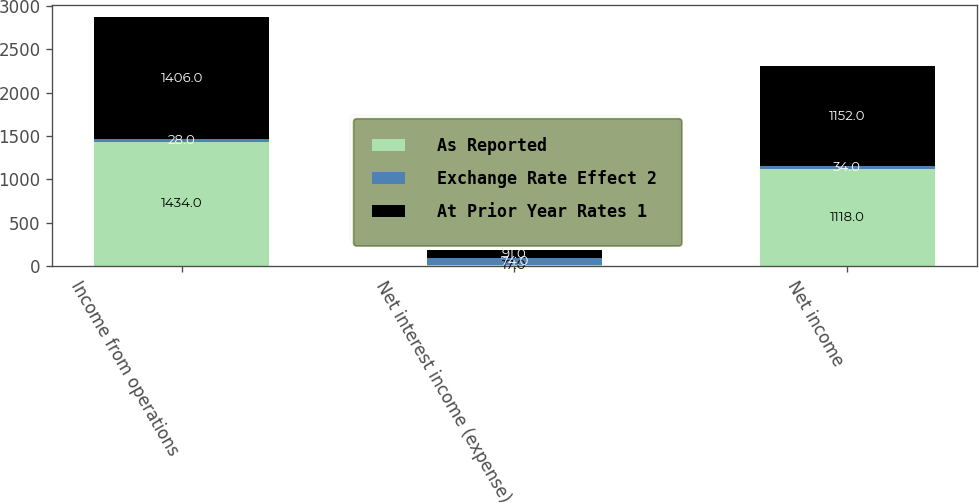Convert chart to OTSL. <chart><loc_0><loc_0><loc_500><loc_500><stacked_bar_chart><ecel><fcel>Income from operations<fcel>Net interest income (expense)<fcel>Net income<nl><fcel>As Reported<fcel>1434<fcel>17<fcel>1118<nl><fcel>Exchange Rate Effect 2<fcel>28<fcel>74<fcel>34<nl><fcel>At Prior Year Rates 1<fcel>1406<fcel>91<fcel>1152<nl></chart> 